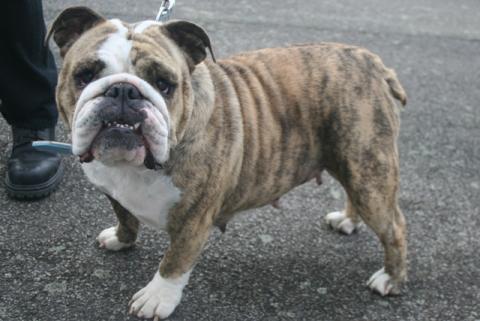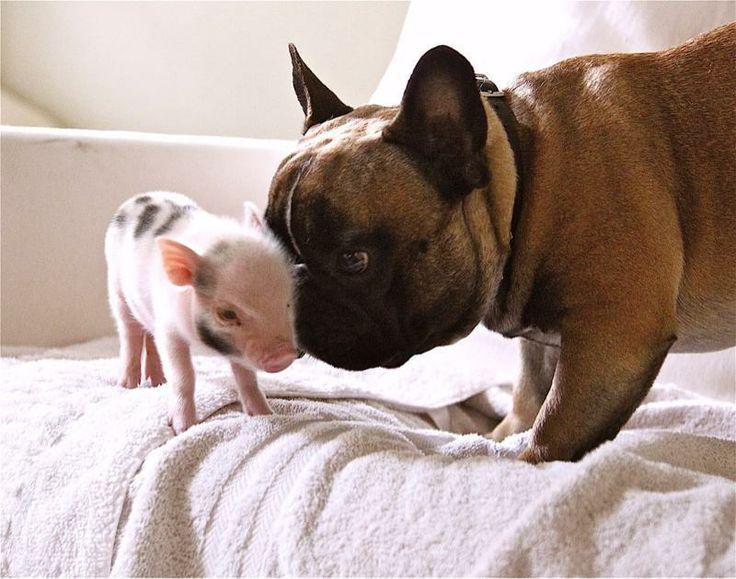The first image is the image on the left, the second image is the image on the right. Considering the images on both sides, is "There are two dogs in the left image." valid? Answer yes or no. No. The first image is the image on the left, the second image is the image on the right. Given the left and right images, does the statement "The left image contains exactly two dogs." hold true? Answer yes or no. No. 